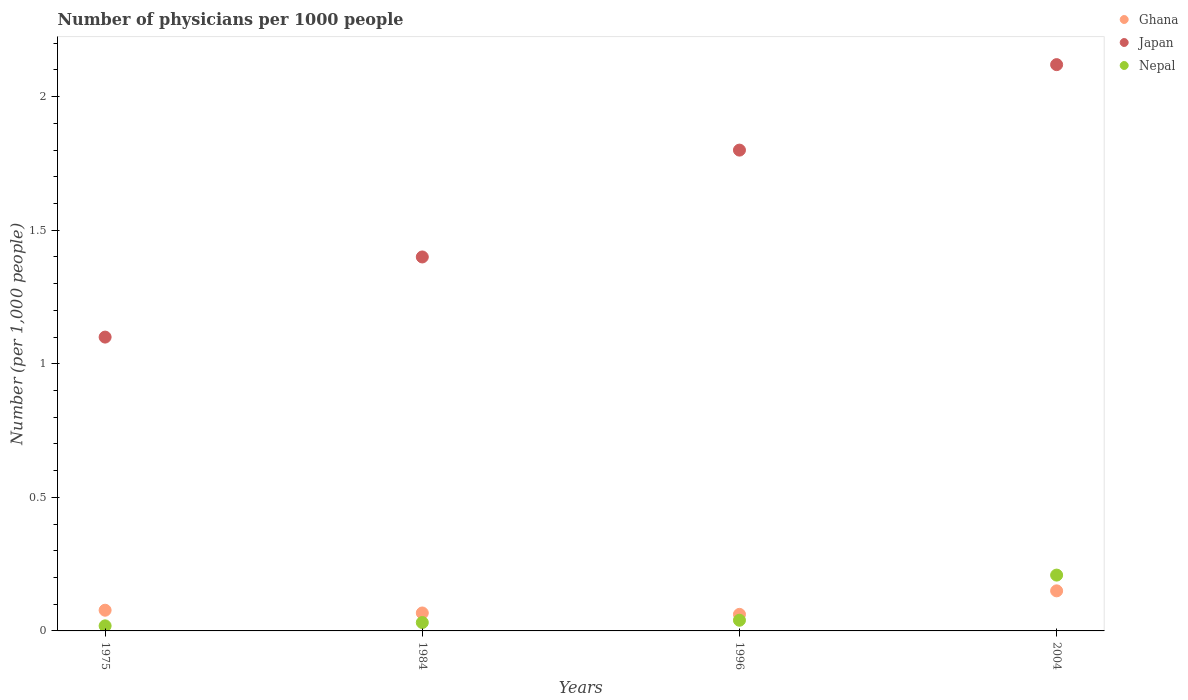Across all years, what is the maximum number of physicians in Nepal?
Offer a terse response. 0.21. Across all years, what is the minimum number of physicians in Ghana?
Make the answer very short. 0.06. In which year was the number of physicians in Nepal maximum?
Keep it short and to the point. 2004. In which year was the number of physicians in Nepal minimum?
Give a very brief answer. 1975. What is the total number of physicians in Japan in the graph?
Your answer should be compact. 6.42. What is the difference between the number of physicians in Japan in 1984 and that in 2004?
Your response must be concise. -0.72. What is the difference between the number of physicians in Japan in 1984 and the number of physicians in Nepal in 1975?
Offer a very short reply. 1.38. What is the average number of physicians in Japan per year?
Your answer should be compact. 1.6. In the year 1984, what is the difference between the number of physicians in Nepal and number of physicians in Japan?
Your answer should be very brief. -1.37. In how many years, is the number of physicians in Japan greater than 1.4?
Keep it short and to the point. 2. What is the ratio of the number of physicians in Nepal in 1975 to that in 2004?
Your answer should be very brief. 0.09. What is the difference between the highest and the second highest number of physicians in Nepal?
Your answer should be compact. 0.17. What is the difference between the highest and the lowest number of physicians in Nepal?
Your answer should be compact. 0.19. In how many years, is the number of physicians in Nepal greater than the average number of physicians in Nepal taken over all years?
Keep it short and to the point. 1. Is it the case that in every year, the sum of the number of physicians in Japan and number of physicians in Ghana  is greater than the number of physicians in Nepal?
Keep it short and to the point. Yes. Does the number of physicians in Ghana monotonically increase over the years?
Make the answer very short. No. Is the number of physicians in Japan strictly greater than the number of physicians in Nepal over the years?
Offer a terse response. Yes. Is the number of physicians in Japan strictly less than the number of physicians in Ghana over the years?
Keep it short and to the point. No. How many dotlines are there?
Provide a short and direct response. 3. How many years are there in the graph?
Offer a terse response. 4. Are the values on the major ticks of Y-axis written in scientific E-notation?
Your answer should be compact. No. Does the graph contain any zero values?
Your response must be concise. No. How many legend labels are there?
Your response must be concise. 3. How are the legend labels stacked?
Your answer should be very brief. Vertical. What is the title of the graph?
Your answer should be very brief. Number of physicians per 1000 people. What is the label or title of the Y-axis?
Your answer should be compact. Number (per 1,0 people). What is the Number (per 1,000 people) in Ghana in 1975?
Make the answer very short. 0.08. What is the Number (per 1,000 people) in Japan in 1975?
Offer a terse response. 1.1. What is the Number (per 1,000 people) of Nepal in 1975?
Your answer should be very brief. 0.02. What is the Number (per 1,000 people) of Ghana in 1984?
Provide a short and direct response. 0.07. What is the Number (per 1,000 people) of Japan in 1984?
Offer a very short reply. 1.4. What is the Number (per 1,000 people) in Nepal in 1984?
Your response must be concise. 0.03. What is the Number (per 1,000 people) in Ghana in 1996?
Offer a very short reply. 0.06. What is the Number (per 1,000 people) of Japan in 2004?
Provide a succinct answer. 2.12. What is the Number (per 1,000 people) in Nepal in 2004?
Your answer should be very brief. 0.21. Across all years, what is the maximum Number (per 1,000 people) of Japan?
Keep it short and to the point. 2.12. Across all years, what is the maximum Number (per 1,000 people) of Nepal?
Give a very brief answer. 0.21. Across all years, what is the minimum Number (per 1,000 people) in Ghana?
Ensure brevity in your answer.  0.06. Across all years, what is the minimum Number (per 1,000 people) in Nepal?
Give a very brief answer. 0.02. What is the total Number (per 1,000 people) in Ghana in the graph?
Your answer should be very brief. 0.36. What is the total Number (per 1,000 people) of Japan in the graph?
Your answer should be compact. 6.42. What is the total Number (per 1,000 people) of Nepal in the graph?
Ensure brevity in your answer.  0.3. What is the difference between the Number (per 1,000 people) in Ghana in 1975 and that in 1984?
Make the answer very short. 0.01. What is the difference between the Number (per 1,000 people) of Nepal in 1975 and that in 1984?
Give a very brief answer. -0.01. What is the difference between the Number (per 1,000 people) of Ghana in 1975 and that in 1996?
Your answer should be very brief. 0.02. What is the difference between the Number (per 1,000 people) of Nepal in 1975 and that in 1996?
Your answer should be compact. -0.02. What is the difference between the Number (per 1,000 people) in Ghana in 1975 and that in 2004?
Make the answer very short. -0.07. What is the difference between the Number (per 1,000 people) of Japan in 1975 and that in 2004?
Keep it short and to the point. -1.02. What is the difference between the Number (per 1,000 people) of Nepal in 1975 and that in 2004?
Your answer should be compact. -0.19. What is the difference between the Number (per 1,000 people) of Ghana in 1984 and that in 1996?
Keep it short and to the point. 0.01. What is the difference between the Number (per 1,000 people) of Nepal in 1984 and that in 1996?
Make the answer very short. -0.01. What is the difference between the Number (per 1,000 people) of Ghana in 1984 and that in 2004?
Your answer should be compact. -0.08. What is the difference between the Number (per 1,000 people) of Japan in 1984 and that in 2004?
Your answer should be very brief. -0.72. What is the difference between the Number (per 1,000 people) in Nepal in 1984 and that in 2004?
Keep it short and to the point. -0.18. What is the difference between the Number (per 1,000 people) of Ghana in 1996 and that in 2004?
Give a very brief answer. -0.09. What is the difference between the Number (per 1,000 people) of Japan in 1996 and that in 2004?
Your answer should be compact. -0.32. What is the difference between the Number (per 1,000 people) of Nepal in 1996 and that in 2004?
Ensure brevity in your answer.  -0.17. What is the difference between the Number (per 1,000 people) in Ghana in 1975 and the Number (per 1,000 people) in Japan in 1984?
Your answer should be very brief. -1.32. What is the difference between the Number (per 1,000 people) of Ghana in 1975 and the Number (per 1,000 people) of Nepal in 1984?
Keep it short and to the point. 0.05. What is the difference between the Number (per 1,000 people) in Japan in 1975 and the Number (per 1,000 people) in Nepal in 1984?
Provide a short and direct response. 1.07. What is the difference between the Number (per 1,000 people) in Ghana in 1975 and the Number (per 1,000 people) in Japan in 1996?
Your answer should be compact. -1.72. What is the difference between the Number (per 1,000 people) in Ghana in 1975 and the Number (per 1,000 people) in Nepal in 1996?
Offer a terse response. 0.04. What is the difference between the Number (per 1,000 people) in Japan in 1975 and the Number (per 1,000 people) in Nepal in 1996?
Your answer should be compact. 1.06. What is the difference between the Number (per 1,000 people) in Ghana in 1975 and the Number (per 1,000 people) in Japan in 2004?
Keep it short and to the point. -2.04. What is the difference between the Number (per 1,000 people) in Ghana in 1975 and the Number (per 1,000 people) in Nepal in 2004?
Ensure brevity in your answer.  -0.13. What is the difference between the Number (per 1,000 people) of Japan in 1975 and the Number (per 1,000 people) of Nepal in 2004?
Make the answer very short. 0.89. What is the difference between the Number (per 1,000 people) in Ghana in 1984 and the Number (per 1,000 people) in Japan in 1996?
Provide a succinct answer. -1.73. What is the difference between the Number (per 1,000 people) in Ghana in 1984 and the Number (per 1,000 people) in Nepal in 1996?
Ensure brevity in your answer.  0.03. What is the difference between the Number (per 1,000 people) of Japan in 1984 and the Number (per 1,000 people) of Nepal in 1996?
Offer a very short reply. 1.36. What is the difference between the Number (per 1,000 people) in Ghana in 1984 and the Number (per 1,000 people) in Japan in 2004?
Provide a short and direct response. -2.05. What is the difference between the Number (per 1,000 people) of Ghana in 1984 and the Number (per 1,000 people) of Nepal in 2004?
Make the answer very short. -0.14. What is the difference between the Number (per 1,000 people) in Japan in 1984 and the Number (per 1,000 people) in Nepal in 2004?
Your answer should be compact. 1.19. What is the difference between the Number (per 1,000 people) in Ghana in 1996 and the Number (per 1,000 people) in Japan in 2004?
Give a very brief answer. -2.06. What is the difference between the Number (per 1,000 people) in Ghana in 1996 and the Number (per 1,000 people) in Nepal in 2004?
Give a very brief answer. -0.15. What is the difference between the Number (per 1,000 people) of Japan in 1996 and the Number (per 1,000 people) of Nepal in 2004?
Offer a very short reply. 1.59. What is the average Number (per 1,000 people) of Ghana per year?
Your answer should be compact. 0.09. What is the average Number (per 1,000 people) of Japan per year?
Give a very brief answer. 1.6. What is the average Number (per 1,000 people) in Nepal per year?
Offer a very short reply. 0.07. In the year 1975, what is the difference between the Number (per 1,000 people) of Ghana and Number (per 1,000 people) of Japan?
Give a very brief answer. -1.02. In the year 1975, what is the difference between the Number (per 1,000 people) in Ghana and Number (per 1,000 people) in Nepal?
Offer a terse response. 0.06. In the year 1975, what is the difference between the Number (per 1,000 people) of Japan and Number (per 1,000 people) of Nepal?
Your response must be concise. 1.08. In the year 1984, what is the difference between the Number (per 1,000 people) of Ghana and Number (per 1,000 people) of Japan?
Provide a succinct answer. -1.33. In the year 1984, what is the difference between the Number (per 1,000 people) of Ghana and Number (per 1,000 people) of Nepal?
Provide a short and direct response. 0.04. In the year 1984, what is the difference between the Number (per 1,000 people) in Japan and Number (per 1,000 people) in Nepal?
Provide a short and direct response. 1.37. In the year 1996, what is the difference between the Number (per 1,000 people) in Ghana and Number (per 1,000 people) in Japan?
Keep it short and to the point. -1.74. In the year 1996, what is the difference between the Number (per 1,000 people) of Ghana and Number (per 1,000 people) of Nepal?
Keep it short and to the point. 0.02. In the year 1996, what is the difference between the Number (per 1,000 people) in Japan and Number (per 1,000 people) in Nepal?
Your answer should be compact. 1.76. In the year 2004, what is the difference between the Number (per 1,000 people) in Ghana and Number (per 1,000 people) in Japan?
Your answer should be very brief. -1.97. In the year 2004, what is the difference between the Number (per 1,000 people) in Ghana and Number (per 1,000 people) in Nepal?
Make the answer very short. -0.06. In the year 2004, what is the difference between the Number (per 1,000 people) of Japan and Number (per 1,000 people) of Nepal?
Offer a terse response. 1.91. What is the ratio of the Number (per 1,000 people) in Ghana in 1975 to that in 1984?
Provide a succinct answer. 1.15. What is the ratio of the Number (per 1,000 people) in Japan in 1975 to that in 1984?
Your answer should be very brief. 0.79. What is the ratio of the Number (per 1,000 people) in Nepal in 1975 to that in 1984?
Keep it short and to the point. 0.61. What is the ratio of the Number (per 1,000 people) of Ghana in 1975 to that in 1996?
Ensure brevity in your answer.  1.25. What is the ratio of the Number (per 1,000 people) in Japan in 1975 to that in 1996?
Provide a succinct answer. 0.61. What is the ratio of the Number (per 1,000 people) in Nepal in 1975 to that in 1996?
Give a very brief answer. 0.47. What is the ratio of the Number (per 1,000 people) in Ghana in 1975 to that in 2004?
Make the answer very short. 0.52. What is the ratio of the Number (per 1,000 people) in Japan in 1975 to that in 2004?
Keep it short and to the point. 0.52. What is the ratio of the Number (per 1,000 people) in Nepal in 1975 to that in 2004?
Offer a very short reply. 0.09. What is the ratio of the Number (per 1,000 people) of Ghana in 1984 to that in 1996?
Provide a short and direct response. 1.08. What is the ratio of the Number (per 1,000 people) of Nepal in 1984 to that in 1996?
Ensure brevity in your answer.  0.79. What is the ratio of the Number (per 1,000 people) in Ghana in 1984 to that in 2004?
Provide a short and direct response. 0.45. What is the ratio of the Number (per 1,000 people) in Japan in 1984 to that in 2004?
Keep it short and to the point. 0.66. What is the ratio of the Number (per 1,000 people) of Nepal in 1984 to that in 2004?
Provide a short and direct response. 0.15. What is the ratio of the Number (per 1,000 people) of Ghana in 1996 to that in 2004?
Offer a terse response. 0.41. What is the ratio of the Number (per 1,000 people) of Japan in 1996 to that in 2004?
Ensure brevity in your answer.  0.85. What is the ratio of the Number (per 1,000 people) of Nepal in 1996 to that in 2004?
Provide a short and direct response. 0.19. What is the difference between the highest and the second highest Number (per 1,000 people) in Ghana?
Give a very brief answer. 0.07. What is the difference between the highest and the second highest Number (per 1,000 people) in Japan?
Your response must be concise. 0.32. What is the difference between the highest and the second highest Number (per 1,000 people) of Nepal?
Offer a terse response. 0.17. What is the difference between the highest and the lowest Number (per 1,000 people) of Ghana?
Make the answer very short. 0.09. What is the difference between the highest and the lowest Number (per 1,000 people) in Japan?
Provide a short and direct response. 1.02. What is the difference between the highest and the lowest Number (per 1,000 people) of Nepal?
Your response must be concise. 0.19. 